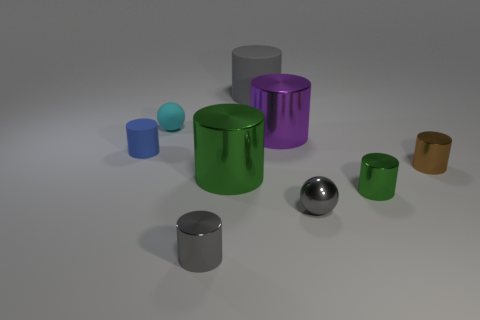Does the brown thing have the same material as the tiny gray sphere that is right of the cyan rubber thing?
Your answer should be very brief. Yes. What shape is the shiny object that is behind the tiny blue matte cylinder?
Give a very brief answer. Cylinder. What number of other objects are there of the same material as the gray ball?
Provide a short and direct response. 5. What size is the gray matte thing?
Offer a very short reply. Large. What number of other things are the same color as the large rubber thing?
Give a very brief answer. 2. What color is the large cylinder that is both to the left of the big purple thing and behind the tiny blue matte thing?
Your answer should be compact. Gray. How many balls are there?
Provide a succinct answer. 2. Are the small blue cylinder and the tiny cyan thing made of the same material?
Ensure brevity in your answer.  Yes. What is the shape of the tiny rubber thing that is behind the matte cylinder that is to the left of the big cylinder behind the tiny cyan matte ball?
Make the answer very short. Sphere. Does the tiny cylinder behind the brown cylinder have the same material as the ball in front of the tiny blue matte object?
Keep it short and to the point. No. 